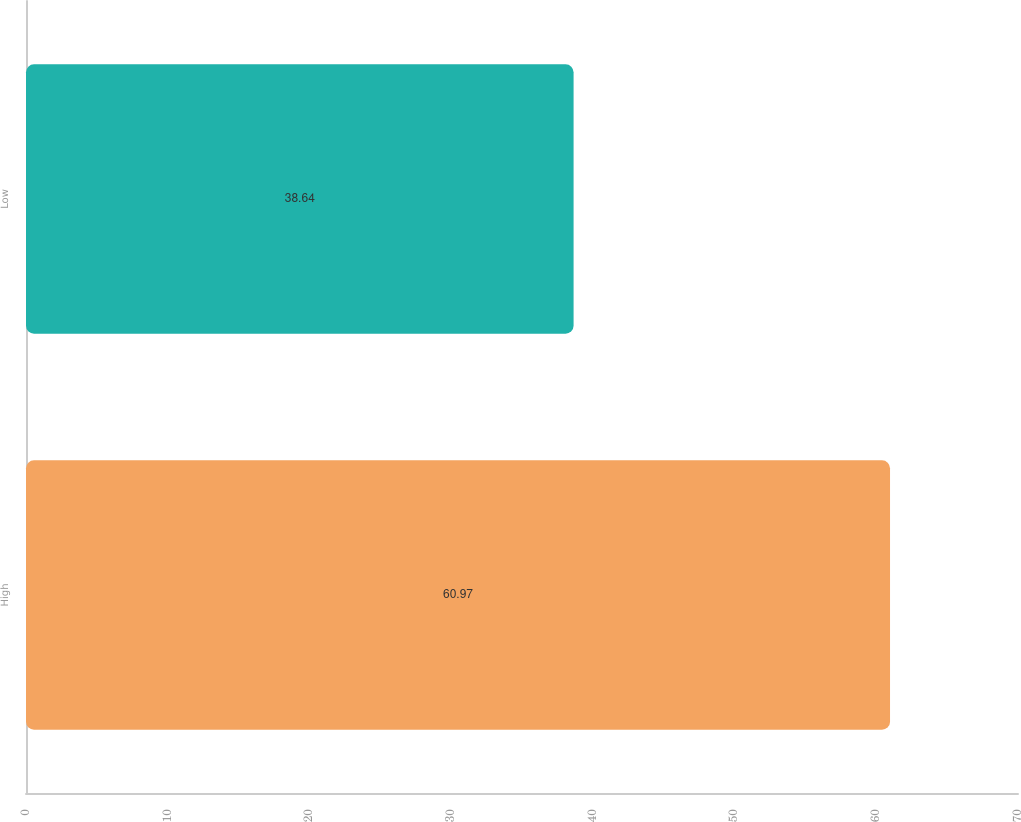Convert chart to OTSL. <chart><loc_0><loc_0><loc_500><loc_500><bar_chart><fcel>High<fcel>Low<nl><fcel>60.97<fcel>38.64<nl></chart> 